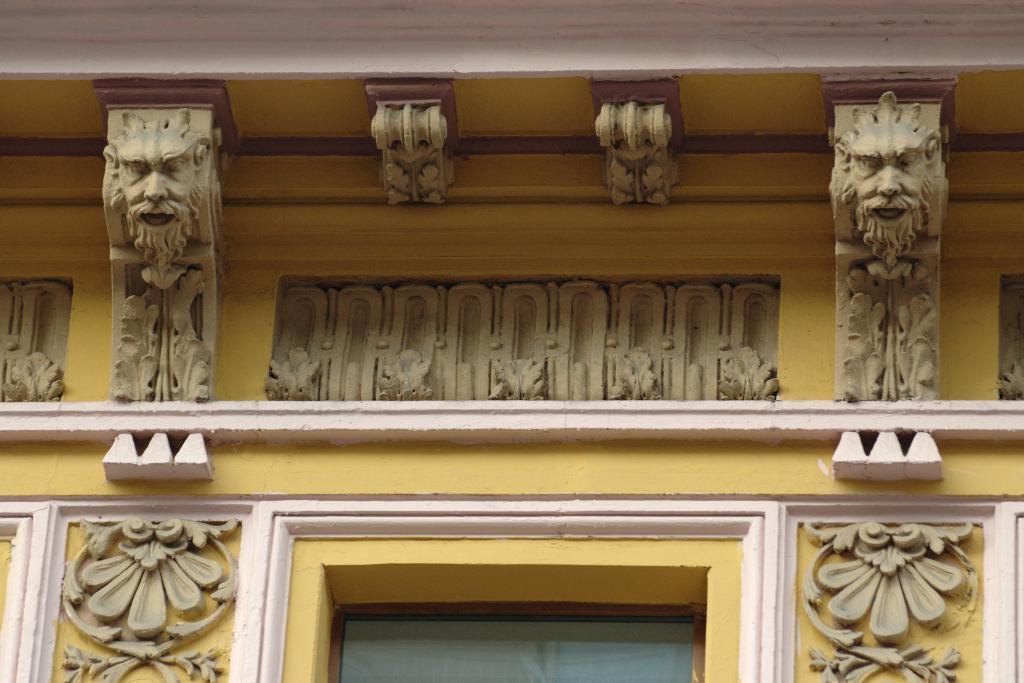Can you describe this image briefly? There is a yellow color building which has few sculptures on it. 